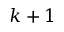Convert formula to latex. <formula><loc_0><loc_0><loc_500><loc_500>k + 1</formula> 